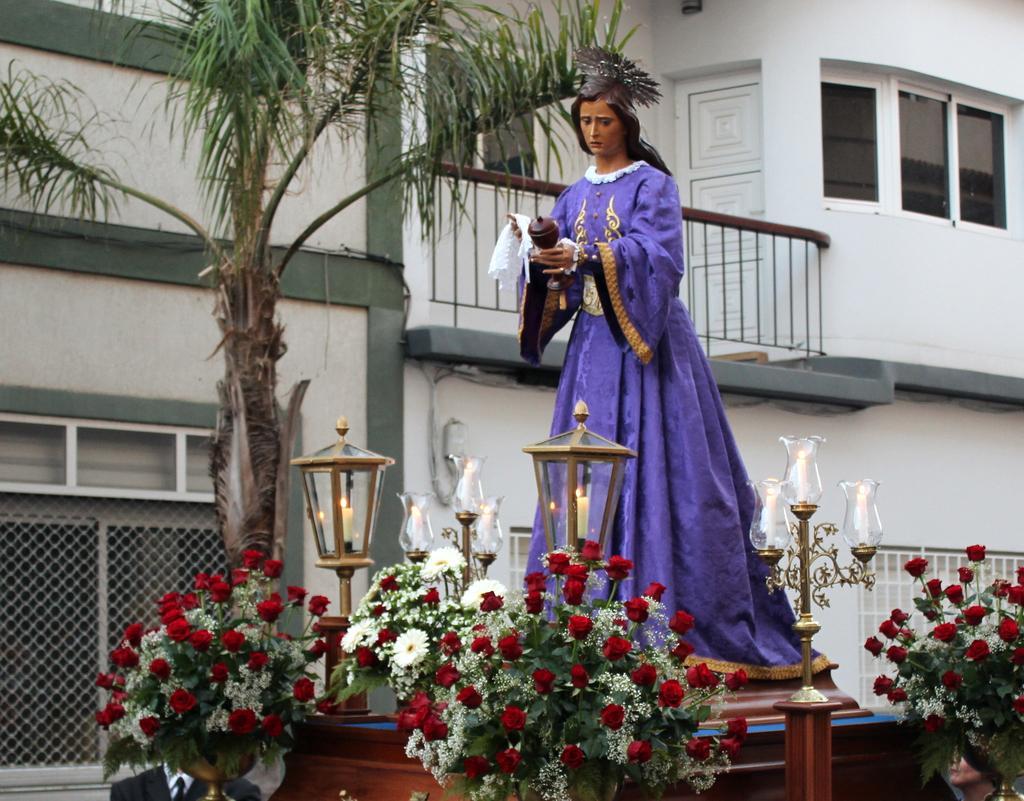How would you summarize this image in a sentence or two? In the picture I can see a statue of a person. I can also see candle lights, red color flowers, a tree and some other objects. In the background I can see a building which has windows. 